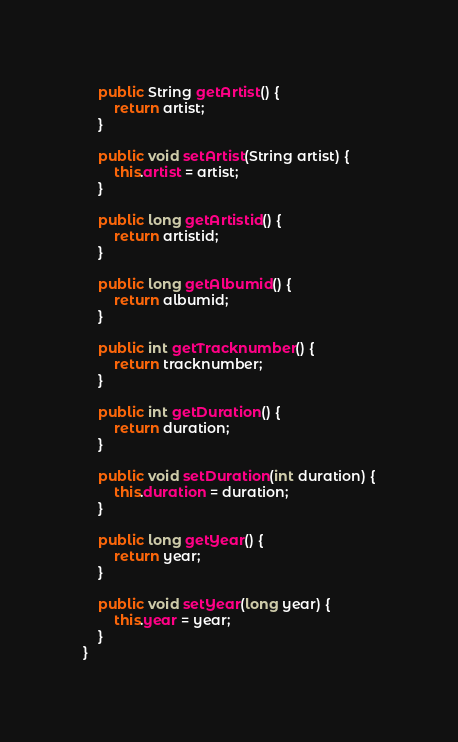Convert code to text. <code><loc_0><loc_0><loc_500><loc_500><_Java_>    public String getArtist() {
        return artist;
    }

    public void setArtist(String artist) {
        this.artist = artist;
    }

    public long getArtistid() {
        return artistid;
    }

    public long getAlbumid() {
        return albumid;
    }

    public int getTracknumber() {
        return tracknumber;
    }

    public int getDuration() {
        return duration;
    }

    public void setDuration(int duration) {
        this.duration = duration;
    }

    public long getYear() {
        return year;
    }

    public void setYear(long year) {
        this.year = year;
    }
}
</code> 